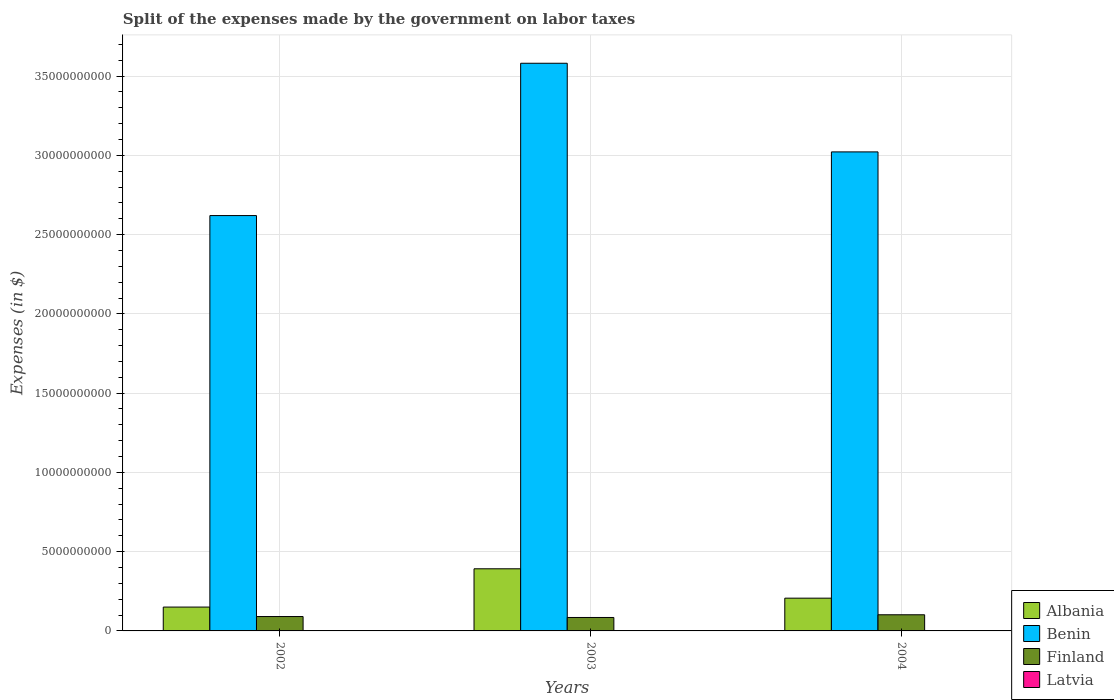How many groups of bars are there?
Your response must be concise. 3. Are the number of bars per tick equal to the number of legend labels?
Give a very brief answer. Yes. How many bars are there on the 3rd tick from the left?
Keep it short and to the point. 4. In how many cases, is the number of bars for a given year not equal to the number of legend labels?
Your answer should be very brief. 0. What is the expenses made by the government on labor taxes in Albania in 2002?
Your answer should be very brief. 1.50e+09. Across all years, what is the maximum expenses made by the government on labor taxes in Latvia?
Your answer should be very brief. 8.60e+06. Across all years, what is the minimum expenses made by the government on labor taxes in Latvia?
Your answer should be very brief. 6.10e+06. In which year was the expenses made by the government on labor taxes in Finland minimum?
Your response must be concise. 2003. What is the total expenses made by the government on labor taxes in Albania in the graph?
Your answer should be compact. 7.49e+09. What is the difference between the expenses made by the government on labor taxes in Latvia in 2003 and that in 2004?
Ensure brevity in your answer.  1.70e+06. What is the difference between the expenses made by the government on labor taxes in Finland in 2003 and the expenses made by the government on labor taxes in Latvia in 2002?
Ensure brevity in your answer.  8.39e+08. What is the average expenses made by the government on labor taxes in Benin per year?
Keep it short and to the point. 3.07e+1. In the year 2002, what is the difference between the expenses made by the government on labor taxes in Finland and expenses made by the government on labor taxes in Latvia?
Your answer should be compact. 8.98e+08. In how many years, is the expenses made by the government on labor taxes in Albania greater than 29000000000 $?
Offer a terse response. 0. What is the ratio of the expenses made by the government on labor taxes in Latvia in 2002 to that in 2003?
Provide a succinct answer. 1.1. Is the expenses made by the government on labor taxes in Finland in 2003 less than that in 2004?
Make the answer very short. Yes. Is the difference between the expenses made by the government on labor taxes in Finland in 2002 and 2004 greater than the difference between the expenses made by the government on labor taxes in Latvia in 2002 and 2004?
Ensure brevity in your answer.  No. What is the difference between the highest and the lowest expenses made by the government on labor taxes in Albania?
Your answer should be very brief. 2.42e+09. What does the 2nd bar from the left in 2004 represents?
Your response must be concise. Benin. What does the 3rd bar from the right in 2004 represents?
Your answer should be compact. Benin. Is it the case that in every year, the sum of the expenses made by the government on labor taxes in Latvia and expenses made by the government on labor taxes in Finland is greater than the expenses made by the government on labor taxes in Albania?
Ensure brevity in your answer.  No. How many bars are there?
Offer a very short reply. 12. Are all the bars in the graph horizontal?
Your answer should be compact. No. How many years are there in the graph?
Keep it short and to the point. 3. What is the difference between two consecutive major ticks on the Y-axis?
Make the answer very short. 5.00e+09. Does the graph contain grids?
Offer a very short reply. Yes. How many legend labels are there?
Offer a very short reply. 4. What is the title of the graph?
Give a very brief answer. Split of the expenses made by the government on labor taxes. What is the label or title of the Y-axis?
Your response must be concise. Expenses (in $). What is the Expenses (in $) of Albania in 2002?
Ensure brevity in your answer.  1.50e+09. What is the Expenses (in $) of Benin in 2002?
Your answer should be very brief. 2.62e+1. What is the Expenses (in $) in Finland in 2002?
Give a very brief answer. 9.07e+08. What is the Expenses (in $) of Latvia in 2002?
Make the answer very short. 8.60e+06. What is the Expenses (in $) in Albania in 2003?
Make the answer very short. 3.92e+09. What is the Expenses (in $) of Benin in 2003?
Keep it short and to the point. 3.58e+1. What is the Expenses (in $) of Finland in 2003?
Your answer should be compact. 8.48e+08. What is the Expenses (in $) in Latvia in 2003?
Provide a short and direct response. 7.80e+06. What is the Expenses (in $) of Albania in 2004?
Provide a short and direct response. 2.07e+09. What is the Expenses (in $) in Benin in 2004?
Ensure brevity in your answer.  3.02e+1. What is the Expenses (in $) in Finland in 2004?
Provide a short and direct response. 1.02e+09. What is the Expenses (in $) of Latvia in 2004?
Provide a short and direct response. 6.10e+06. Across all years, what is the maximum Expenses (in $) of Albania?
Ensure brevity in your answer.  3.92e+09. Across all years, what is the maximum Expenses (in $) in Benin?
Ensure brevity in your answer.  3.58e+1. Across all years, what is the maximum Expenses (in $) in Finland?
Provide a succinct answer. 1.02e+09. Across all years, what is the maximum Expenses (in $) of Latvia?
Your response must be concise. 8.60e+06. Across all years, what is the minimum Expenses (in $) of Albania?
Your answer should be very brief. 1.50e+09. Across all years, what is the minimum Expenses (in $) in Benin?
Ensure brevity in your answer.  2.62e+1. Across all years, what is the minimum Expenses (in $) in Finland?
Ensure brevity in your answer.  8.48e+08. Across all years, what is the minimum Expenses (in $) of Latvia?
Your response must be concise. 6.10e+06. What is the total Expenses (in $) of Albania in the graph?
Give a very brief answer. 7.49e+09. What is the total Expenses (in $) of Benin in the graph?
Ensure brevity in your answer.  9.22e+1. What is the total Expenses (in $) in Finland in the graph?
Ensure brevity in your answer.  2.77e+09. What is the total Expenses (in $) in Latvia in the graph?
Your answer should be compact. 2.25e+07. What is the difference between the Expenses (in $) in Albania in 2002 and that in 2003?
Provide a short and direct response. -2.42e+09. What is the difference between the Expenses (in $) of Benin in 2002 and that in 2003?
Your answer should be very brief. -9.61e+09. What is the difference between the Expenses (in $) of Finland in 2002 and that in 2003?
Ensure brevity in your answer.  5.90e+07. What is the difference between the Expenses (in $) in Latvia in 2002 and that in 2003?
Make the answer very short. 8.00e+05. What is the difference between the Expenses (in $) in Albania in 2002 and that in 2004?
Keep it short and to the point. -5.62e+08. What is the difference between the Expenses (in $) in Benin in 2002 and that in 2004?
Your answer should be very brief. -4.02e+09. What is the difference between the Expenses (in $) of Finland in 2002 and that in 2004?
Keep it short and to the point. -1.12e+08. What is the difference between the Expenses (in $) in Latvia in 2002 and that in 2004?
Provide a succinct answer. 2.50e+06. What is the difference between the Expenses (in $) in Albania in 2003 and that in 2004?
Provide a short and direct response. 1.85e+09. What is the difference between the Expenses (in $) in Benin in 2003 and that in 2004?
Offer a terse response. 5.59e+09. What is the difference between the Expenses (in $) of Finland in 2003 and that in 2004?
Make the answer very short. -1.71e+08. What is the difference between the Expenses (in $) in Latvia in 2003 and that in 2004?
Offer a very short reply. 1.70e+06. What is the difference between the Expenses (in $) of Albania in 2002 and the Expenses (in $) of Benin in 2003?
Provide a succinct answer. -3.43e+1. What is the difference between the Expenses (in $) of Albania in 2002 and the Expenses (in $) of Finland in 2003?
Provide a succinct answer. 6.56e+08. What is the difference between the Expenses (in $) in Albania in 2002 and the Expenses (in $) in Latvia in 2003?
Offer a very short reply. 1.50e+09. What is the difference between the Expenses (in $) of Benin in 2002 and the Expenses (in $) of Finland in 2003?
Provide a short and direct response. 2.54e+1. What is the difference between the Expenses (in $) in Benin in 2002 and the Expenses (in $) in Latvia in 2003?
Provide a succinct answer. 2.62e+1. What is the difference between the Expenses (in $) in Finland in 2002 and the Expenses (in $) in Latvia in 2003?
Ensure brevity in your answer.  8.99e+08. What is the difference between the Expenses (in $) of Albania in 2002 and the Expenses (in $) of Benin in 2004?
Ensure brevity in your answer.  -2.87e+1. What is the difference between the Expenses (in $) in Albania in 2002 and the Expenses (in $) in Finland in 2004?
Provide a succinct answer. 4.85e+08. What is the difference between the Expenses (in $) in Albania in 2002 and the Expenses (in $) in Latvia in 2004?
Make the answer very short. 1.50e+09. What is the difference between the Expenses (in $) of Benin in 2002 and the Expenses (in $) of Finland in 2004?
Provide a short and direct response. 2.52e+1. What is the difference between the Expenses (in $) in Benin in 2002 and the Expenses (in $) in Latvia in 2004?
Your answer should be very brief. 2.62e+1. What is the difference between the Expenses (in $) in Finland in 2002 and the Expenses (in $) in Latvia in 2004?
Your response must be concise. 9.01e+08. What is the difference between the Expenses (in $) in Albania in 2003 and the Expenses (in $) in Benin in 2004?
Provide a succinct answer. -2.63e+1. What is the difference between the Expenses (in $) in Albania in 2003 and the Expenses (in $) in Finland in 2004?
Provide a short and direct response. 2.90e+09. What is the difference between the Expenses (in $) of Albania in 2003 and the Expenses (in $) of Latvia in 2004?
Give a very brief answer. 3.91e+09. What is the difference between the Expenses (in $) of Benin in 2003 and the Expenses (in $) of Finland in 2004?
Offer a terse response. 3.48e+1. What is the difference between the Expenses (in $) in Benin in 2003 and the Expenses (in $) in Latvia in 2004?
Provide a short and direct response. 3.58e+1. What is the difference between the Expenses (in $) in Finland in 2003 and the Expenses (in $) in Latvia in 2004?
Give a very brief answer. 8.42e+08. What is the average Expenses (in $) of Albania per year?
Provide a short and direct response. 2.50e+09. What is the average Expenses (in $) of Benin per year?
Your response must be concise. 3.07e+1. What is the average Expenses (in $) in Finland per year?
Your response must be concise. 9.25e+08. What is the average Expenses (in $) of Latvia per year?
Provide a short and direct response. 7.50e+06. In the year 2002, what is the difference between the Expenses (in $) in Albania and Expenses (in $) in Benin?
Your response must be concise. -2.47e+1. In the year 2002, what is the difference between the Expenses (in $) of Albania and Expenses (in $) of Finland?
Keep it short and to the point. 5.97e+08. In the year 2002, what is the difference between the Expenses (in $) in Albania and Expenses (in $) in Latvia?
Your response must be concise. 1.50e+09. In the year 2002, what is the difference between the Expenses (in $) of Benin and Expenses (in $) of Finland?
Provide a succinct answer. 2.53e+1. In the year 2002, what is the difference between the Expenses (in $) of Benin and Expenses (in $) of Latvia?
Give a very brief answer. 2.62e+1. In the year 2002, what is the difference between the Expenses (in $) of Finland and Expenses (in $) of Latvia?
Give a very brief answer. 8.98e+08. In the year 2003, what is the difference between the Expenses (in $) of Albania and Expenses (in $) of Benin?
Offer a terse response. -3.19e+1. In the year 2003, what is the difference between the Expenses (in $) of Albania and Expenses (in $) of Finland?
Keep it short and to the point. 3.07e+09. In the year 2003, what is the difference between the Expenses (in $) in Albania and Expenses (in $) in Latvia?
Provide a short and direct response. 3.91e+09. In the year 2003, what is the difference between the Expenses (in $) of Benin and Expenses (in $) of Finland?
Make the answer very short. 3.50e+1. In the year 2003, what is the difference between the Expenses (in $) of Benin and Expenses (in $) of Latvia?
Provide a succinct answer. 3.58e+1. In the year 2003, what is the difference between the Expenses (in $) of Finland and Expenses (in $) of Latvia?
Make the answer very short. 8.40e+08. In the year 2004, what is the difference between the Expenses (in $) in Albania and Expenses (in $) in Benin?
Ensure brevity in your answer.  -2.82e+1. In the year 2004, what is the difference between the Expenses (in $) of Albania and Expenses (in $) of Finland?
Your answer should be compact. 1.05e+09. In the year 2004, what is the difference between the Expenses (in $) in Albania and Expenses (in $) in Latvia?
Keep it short and to the point. 2.06e+09. In the year 2004, what is the difference between the Expenses (in $) in Benin and Expenses (in $) in Finland?
Ensure brevity in your answer.  2.92e+1. In the year 2004, what is the difference between the Expenses (in $) in Benin and Expenses (in $) in Latvia?
Offer a very short reply. 3.02e+1. In the year 2004, what is the difference between the Expenses (in $) of Finland and Expenses (in $) of Latvia?
Offer a very short reply. 1.01e+09. What is the ratio of the Expenses (in $) in Albania in 2002 to that in 2003?
Keep it short and to the point. 0.38. What is the ratio of the Expenses (in $) in Benin in 2002 to that in 2003?
Make the answer very short. 0.73. What is the ratio of the Expenses (in $) of Finland in 2002 to that in 2003?
Provide a succinct answer. 1.07. What is the ratio of the Expenses (in $) of Latvia in 2002 to that in 2003?
Provide a succinct answer. 1.1. What is the ratio of the Expenses (in $) in Albania in 2002 to that in 2004?
Ensure brevity in your answer.  0.73. What is the ratio of the Expenses (in $) in Benin in 2002 to that in 2004?
Provide a short and direct response. 0.87. What is the ratio of the Expenses (in $) of Finland in 2002 to that in 2004?
Offer a terse response. 0.89. What is the ratio of the Expenses (in $) in Latvia in 2002 to that in 2004?
Keep it short and to the point. 1.41. What is the ratio of the Expenses (in $) in Albania in 2003 to that in 2004?
Keep it short and to the point. 1.9. What is the ratio of the Expenses (in $) of Benin in 2003 to that in 2004?
Keep it short and to the point. 1.19. What is the ratio of the Expenses (in $) in Finland in 2003 to that in 2004?
Your response must be concise. 0.83. What is the ratio of the Expenses (in $) of Latvia in 2003 to that in 2004?
Give a very brief answer. 1.28. What is the difference between the highest and the second highest Expenses (in $) of Albania?
Your response must be concise. 1.85e+09. What is the difference between the highest and the second highest Expenses (in $) of Benin?
Provide a short and direct response. 5.59e+09. What is the difference between the highest and the second highest Expenses (in $) of Finland?
Keep it short and to the point. 1.12e+08. What is the difference between the highest and the second highest Expenses (in $) of Latvia?
Give a very brief answer. 8.00e+05. What is the difference between the highest and the lowest Expenses (in $) in Albania?
Offer a terse response. 2.42e+09. What is the difference between the highest and the lowest Expenses (in $) in Benin?
Provide a succinct answer. 9.61e+09. What is the difference between the highest and the lowest Expenses (in $) of Finland?
Make the answer very short. 1.71e+08. What is the difference between the highest and the lowest Expenses (in $) of Latvia?
Provide a short and direct response. 2.50e+06. 